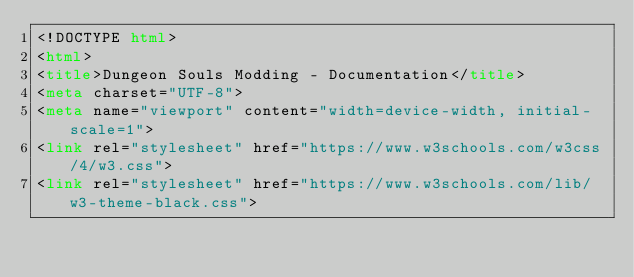Convert code to text. <code><loc_0><loc_0><loc_500><loc_500><_HTML_><!DOCTYPE html>
<html>
<title>Dungeon Souls Modding - Documentation</title>
<meta charset="UTF-8">
<meta name="viewport" content="width=device-width, initial-scale=1">
<link rel="stylesheet" href="https://www.w3schools.com/w3css/4/w3.css">
<link rel="stylesheet" href="https://www.w3schools.com/lib/w3-theme-black.css"></code> 